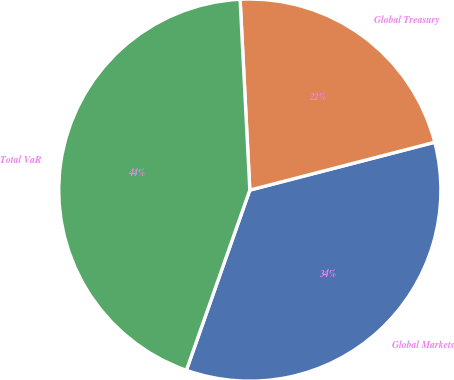Convert chart to OTSL. <chart><loc_0><loc_0><loc_500><loc_500><pie_chart><fcel>Global Markets<fcel>Global Treasury<fcel>Total VaR<nl><fcel>34.42%<fcel>21.78%<fcel>43.8%<nl></chart> 